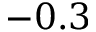Convert formula to latex. <formula><loc_0><loc_0><loc_500><loc_500>- 0 . 3</formula> 